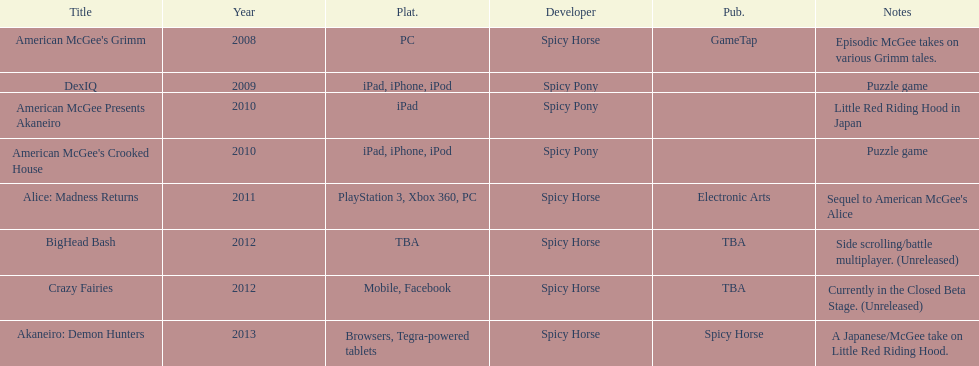On how many platforms was american mcgee's grimm available? 1. 